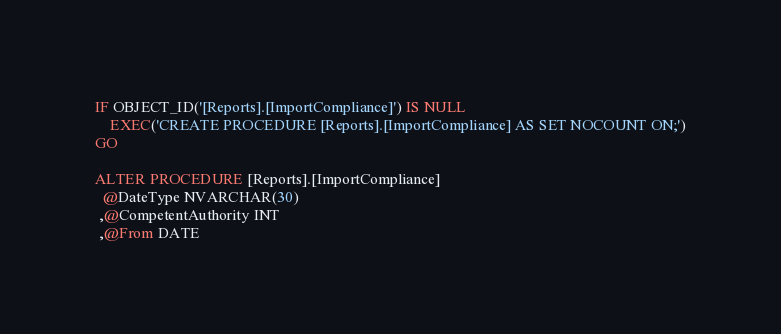Convert code to text. <code><loc_0><loc_0><loc_500><loc_500><_SQL_>IF OBJECT_ID('[Reports].[ImportCompliance]') IS NULL
    EXEC('CREATE PROCEDURE [Reports].[ImportCompliance] AS SET NOCOUNT ON;')
GO

ALTER PROCEDURE [Reports].[ImportCompliance]
  @DateType NVARCHAR(30)
 ,@CompetentAuthority INT
 ,@From DATE</code> 